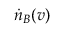Convert formula to latex. <formula><loc_0><loc_0><loc_500><loc_500>\dot { n } _ { B } ( v )</formula> 